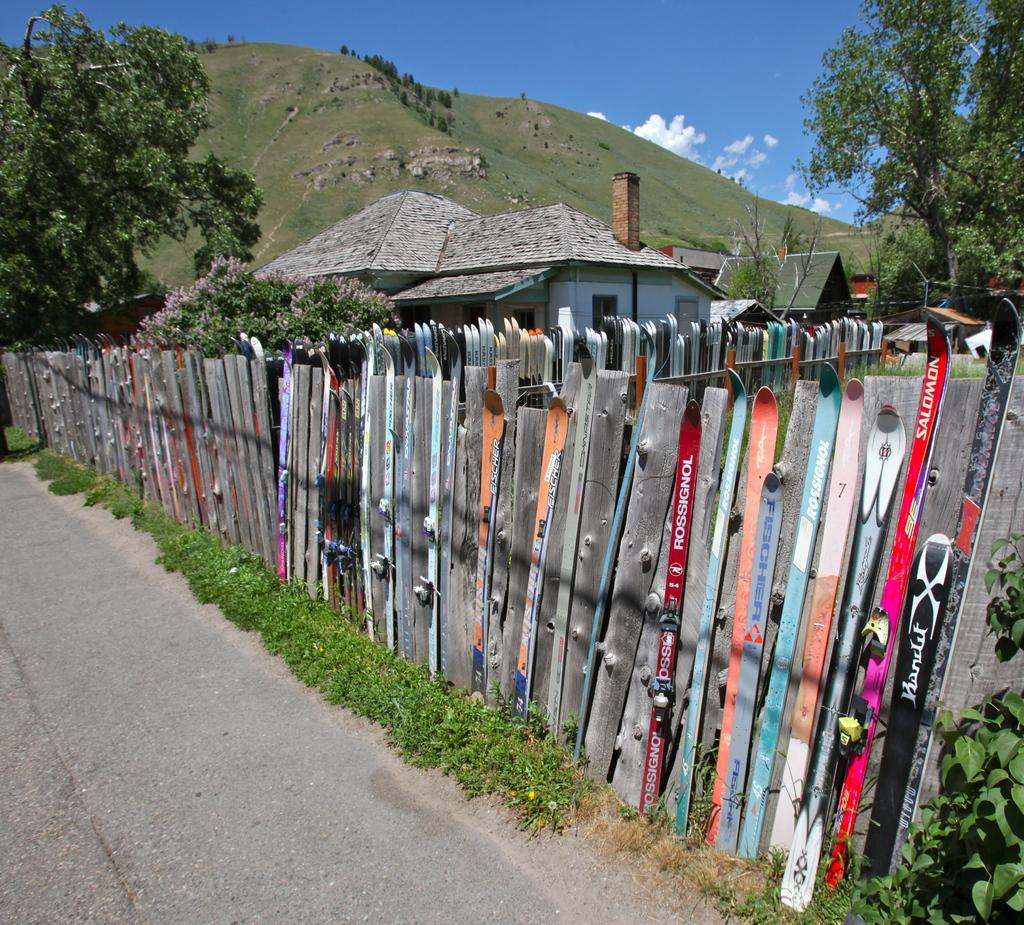What type of structure can be seen in the image? There is a fence in the image. What can be seen beside the road in the image? There are plants beside the road in the image. Where is the shelter house located in the image? The shelter house is in between trees in the image. What geographical feature is visible in the image? There is a hill visible in the image. What is visible at the top of the image? The sky is visible at the top of the image. How many boys are playing with the curtain in the image? There are no boys or curtains present in the image. What type of voyage is depicted in the image? There is no voyage depicted in the image; it features a fence, plants, a shelter house, a hill, and the sky. 